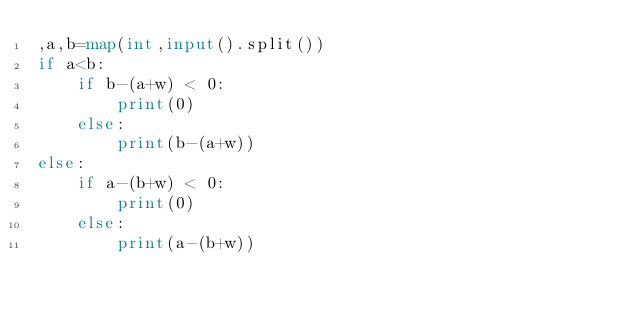<code> <loc_0><loc_0><loc_500><loc_500><_Python_>,a,b=map(int,input().split())
if a<b:
    if b-(a+w) < 0:
        print(0)
    else:
        print(b-(a+w))
else:
    if a-(b+w) < 0:
        print(0)
    else:
        print(a-(b+w))</code> 